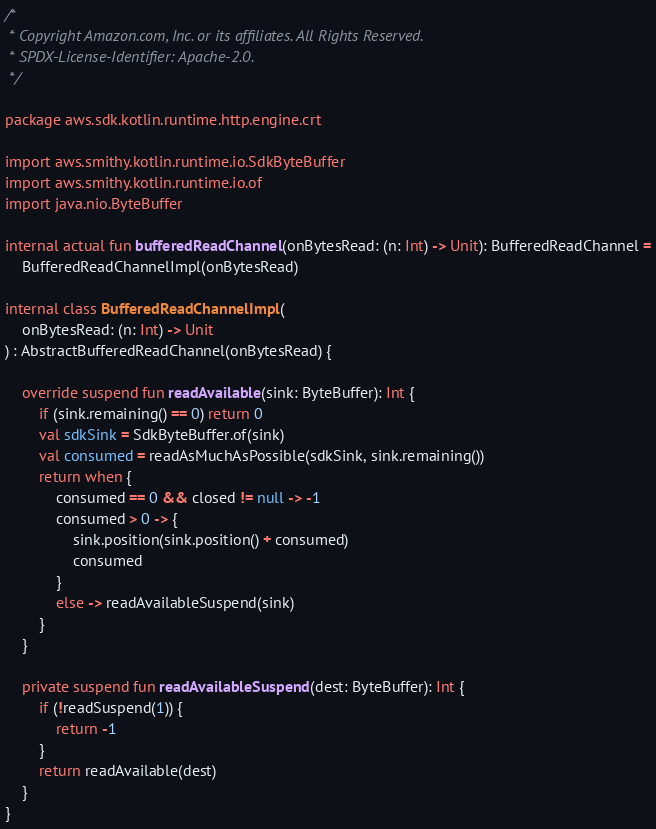Convert code to text. <code><loc_0><loc_0><loc_500><loc_500><_Kotlin_>/*
 * Copyright Amazon.com, Inc. or its affiliates. All Rights Reserved.
 * SPDX-License-Identifier: Apache-2.0.
 */

package aws.sdk.kotlin.runtime.http.engine.crt

import aws.smithy.kotlin.runtime.io.SdkByteBuffer
import aws.smithy.kotlin.runtime.io.of
import java.nio.ByteBuffer

internal actual fun bufferedReadChannel(onBytesRead: (n: Int) -> Unit): BufferedReadChannel =
    BufferedReadChannelImpl(onBytesRead)

internal class BufferedReadChannelImpl(
    onBytesRead: (n: Int) -> Unit
) : AbstractBufferedReadChannel(onBytesRead) {

    override suspend fun readAvailable(sink: ByteBuffer): Int {
        if (sink.remaining() == 0) return 0
        val sdkSink = SdkByteBuffer.of(sink)
        val consumed = readAsMuchAsPossible(sdkSink, sink.remaining())
        return when {
            consumed == 0 && closed != null -> -1
            consumed > 0 -> {
                sink.position(sink.position() + consumed)
                consumed
            }
            else -> readAvailableSuspend(sink)
        }
    }

    private suspend fun readAvailableSuspend(dest: ByteBuffer): Int {
        if (!readSuspend(1)) {
            return -1
        }
        return readAvailable(dest)
    }
}
</code> 